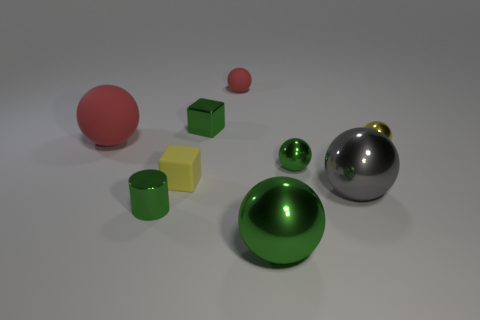How many shiny things are to the left of the big gray metallic thing and right of the large gray metal object?
Give a very brief answer. 0. There is a tiny thing that is in front of the tiny matte object in front of the small red sphere that is to the right of the small yellow cube; what color is it?
Offer a terse response. Green. How many other objects are the same shape as the small red thing?
Make the answer very short. 5. Is there a green object right of the small yellow object to the left of the small red sphere?
Offer a very short reply. Yes. How many matte objects are either small yellow objects or big purple balls?
Offer a very short reply. 1. What is the big thing that is both behind the big green metallic object and left of the gray sphere made of?
Provide a succinct answer. Rubber. There is a red matte sphere that is left of the red sphere that is on the right side of the matte block; are there any big green shiny spheres in front of it?
Your answer should be very brief. Yes. The tiny yellow thing that is made of the same material as the small green ball is what shape?
Make the answer very short. Sphere. Are there fewer small cylinders that are behind the small green sphere than big red rubber objects that are behind the big red rubber object?
Your answer should be very brief. No. What number of big objects are matte objects or green things?
Give a very brief answer. 2. 